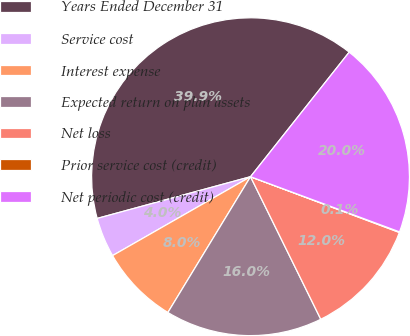Convert chart. <chart><loc_0><loc_0><loc_500><loc_500><pie_chart><fcel>Years Ended December 31<fcel>Service cost<fcel>Interest expense<fcel>Expected return on plan assets<fcel>Net loss<fcel>Prior service cost (credit)<fcel>Net periodic cost (credit)<nl><fcel>39.89%<fcel>4.04%<fcel>8.03%<fcel>15.99%<fcel>12.01%<fcel>0.06%<fcel>19.98%<nl></chart> 